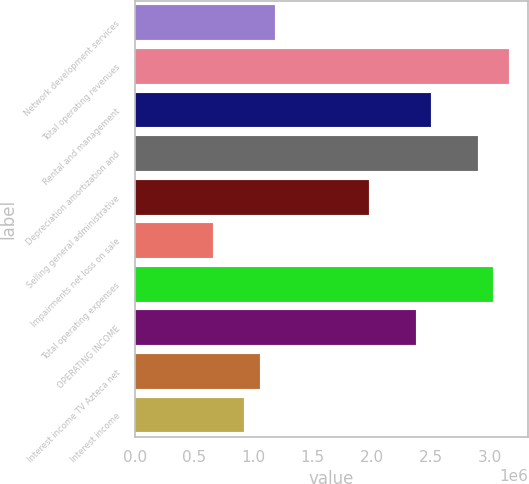Convert chart. <chart><loc_0><loc_0><loc_500><loc_500><bar_chart><fcel>Network development services<fcel>Total operating revenues<fcel>Rental and management<fcel>Depreciation amortization and<fcel>Selling general administrative<fcel>Impairments net loss on sale<fcel>Total operating expenses<fcel>OPERATING INCOME<fcel>Interest income TV Azteca net<fcel>Interest income<nl><fcel>1.18565e+06<fcel>3.16172e+06<fcel>2.50303e+06<fcel>2.89825e+06<fcel>1.97608e+06<fcel>658693<fcel>3.02999e+06<fcel>2.37129e+06<fcel>1.05391e+06<fcel>922169<nl></chart> 